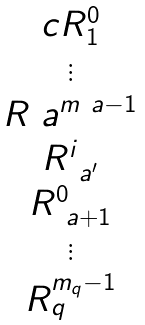Convert formula to latex. <formula><loc_0><loc_0><loc_500><loc_500>\begin{matrix} { c } R _ { 1 } ^ { 0 } \\ \vdots \\ R _ { \ } a ^ { m _ { \ } a - 1 } \\ R ^ { i } _ { \ a ^ { \prime } } \\ R _ { \ a + 1 } ^ { 0 } \\ \vdots \\ R _ { q } ^ { m _ { q } - 1 } \end{matrix}</formula> 